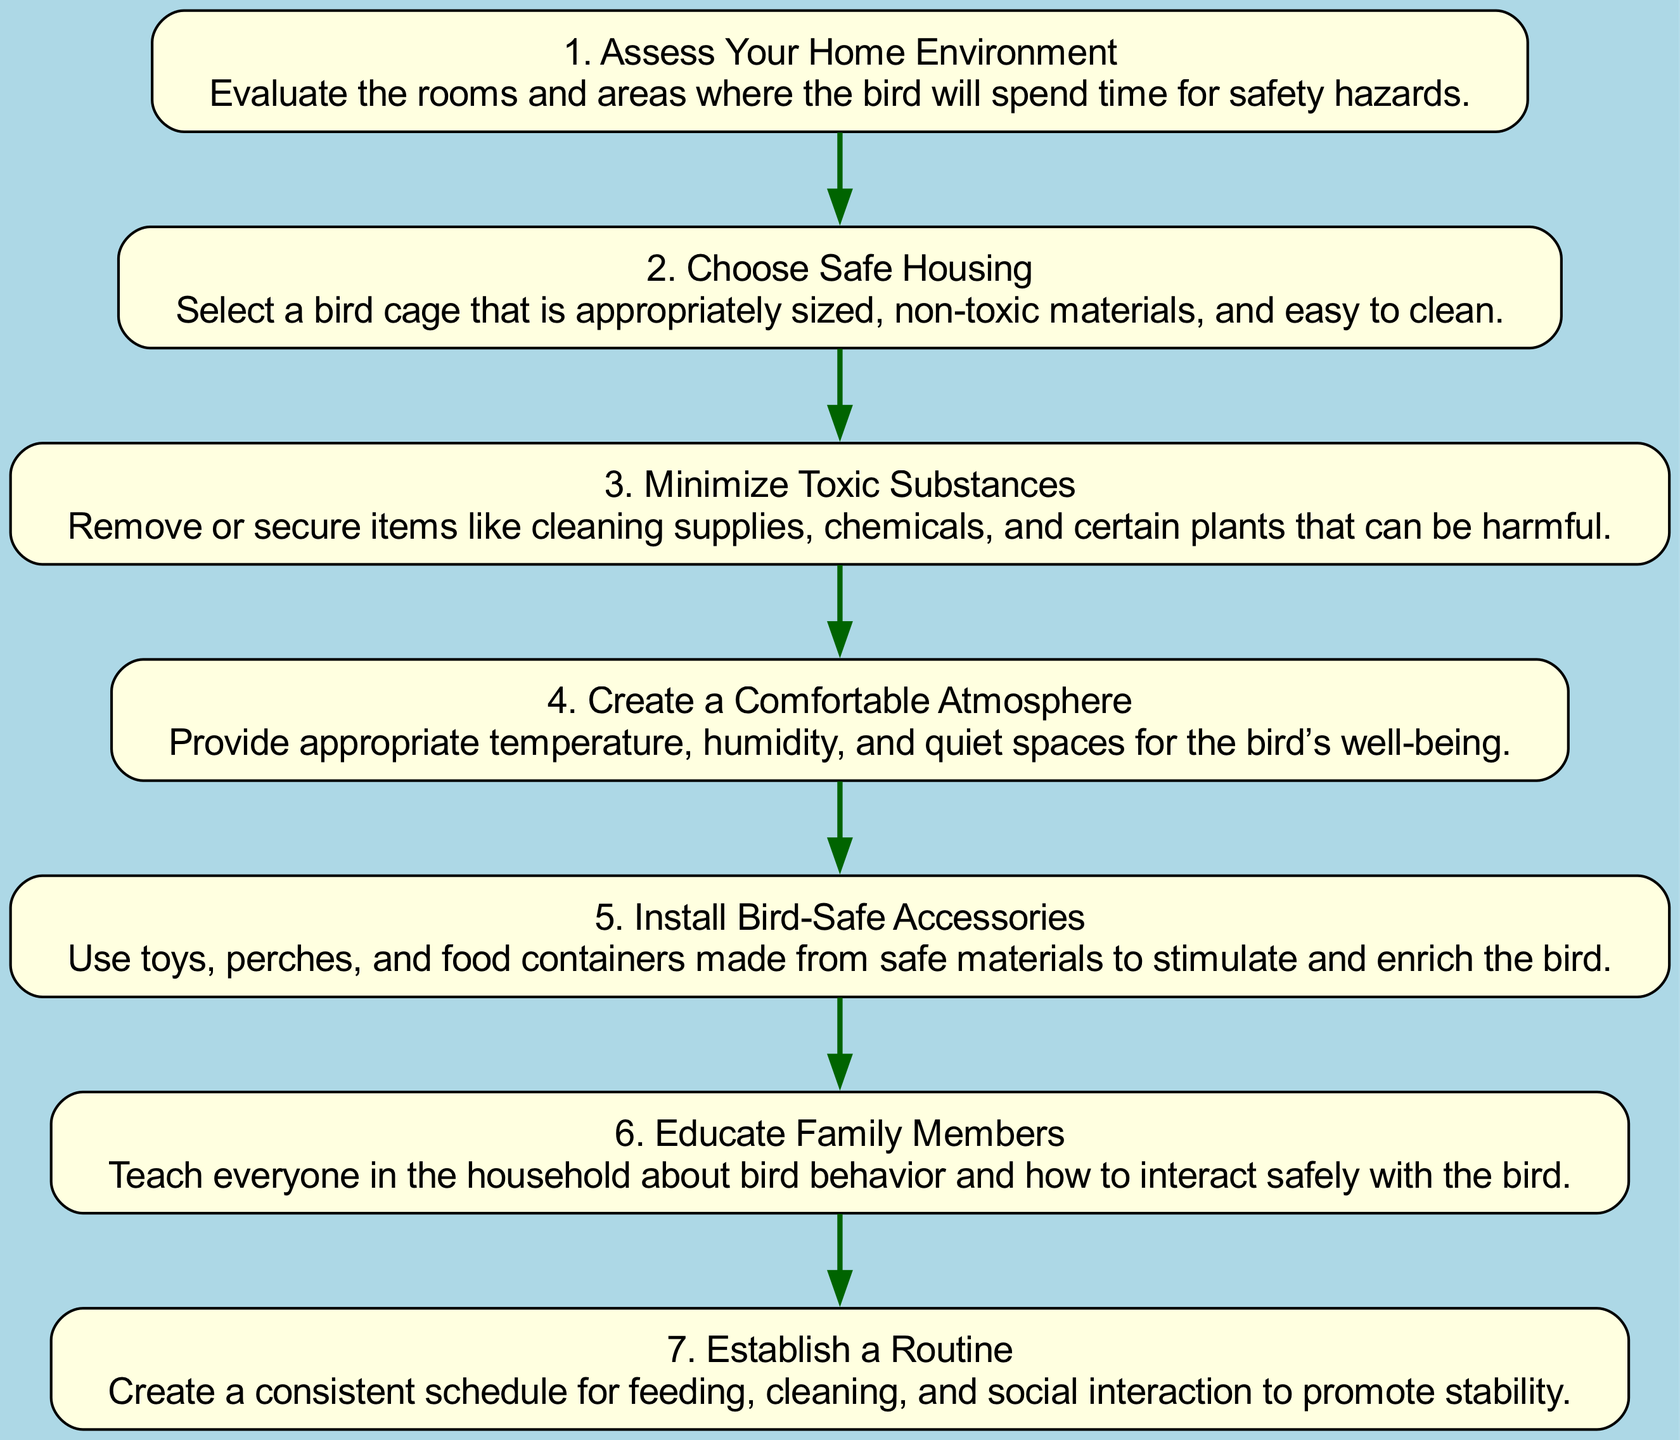What is the first step in the flow chart? The flow chart starts with the node labeled "1. Assess Your Home Environment," indicating it is the first step for creating a safe bird environment.
Answer: Assess Your Home Environment How many steps are there in total? By counting the nodes in the flow chart, there are a total of seven distinct steps listed.
Answer: 7 What is the title of the fourth step? The fourth node in the flow chart is labeled "4. Create a Comfortable Atmosphere," which represents the specific action required at this stage.
Answer: Create a Comfortable Atmosphere Which step follows "Minimize Toxic Substances"? The step immediately following "Minimize Toxic Substances" (the third step) is "Create a Comfortable Atmosphere," meaning it represents the next action in the sequence.
Answer: Create a Comfortable Atmosphere What do you do during the sixth step? In the sixth step, the flow chart indicates the action "Educate Family Members," which involves teaching household members about bird behavior.
Answer: Educate Family Members Which two steps are focused on the environment's physical conditions? The steps "Create a Comfortable Atmosphere" and "Choose Safe Housing" relate directly to the physical aspects of the bird's living environment.
Answer: Create a Comfortable Atmosphere and Choose Safe Housing Which step is directly before "Establish a Routine"? The step that comes just before "Establish a Routine" is "Educate Family Members," as indicated by the sequential arrangement of the nodes.
Answer: Educate Family Members What does the step "Install Bird-Safe Accessories" focus on? This step emphasizes ensuring that all toys, perches, and food containers used are made from safe materials for the bird's stimulation and enrichment.
Answer: Use toys, perches, and food containers made from safe materials Which two steps are related to safety and education? "Minimize Toxic Substances" and "Educate Family Members" are both directed at ensuring safety in the bird's environment and teaching the proper handling of birds.
Answer: Minimize Toxic Substances and Educate Family Members 